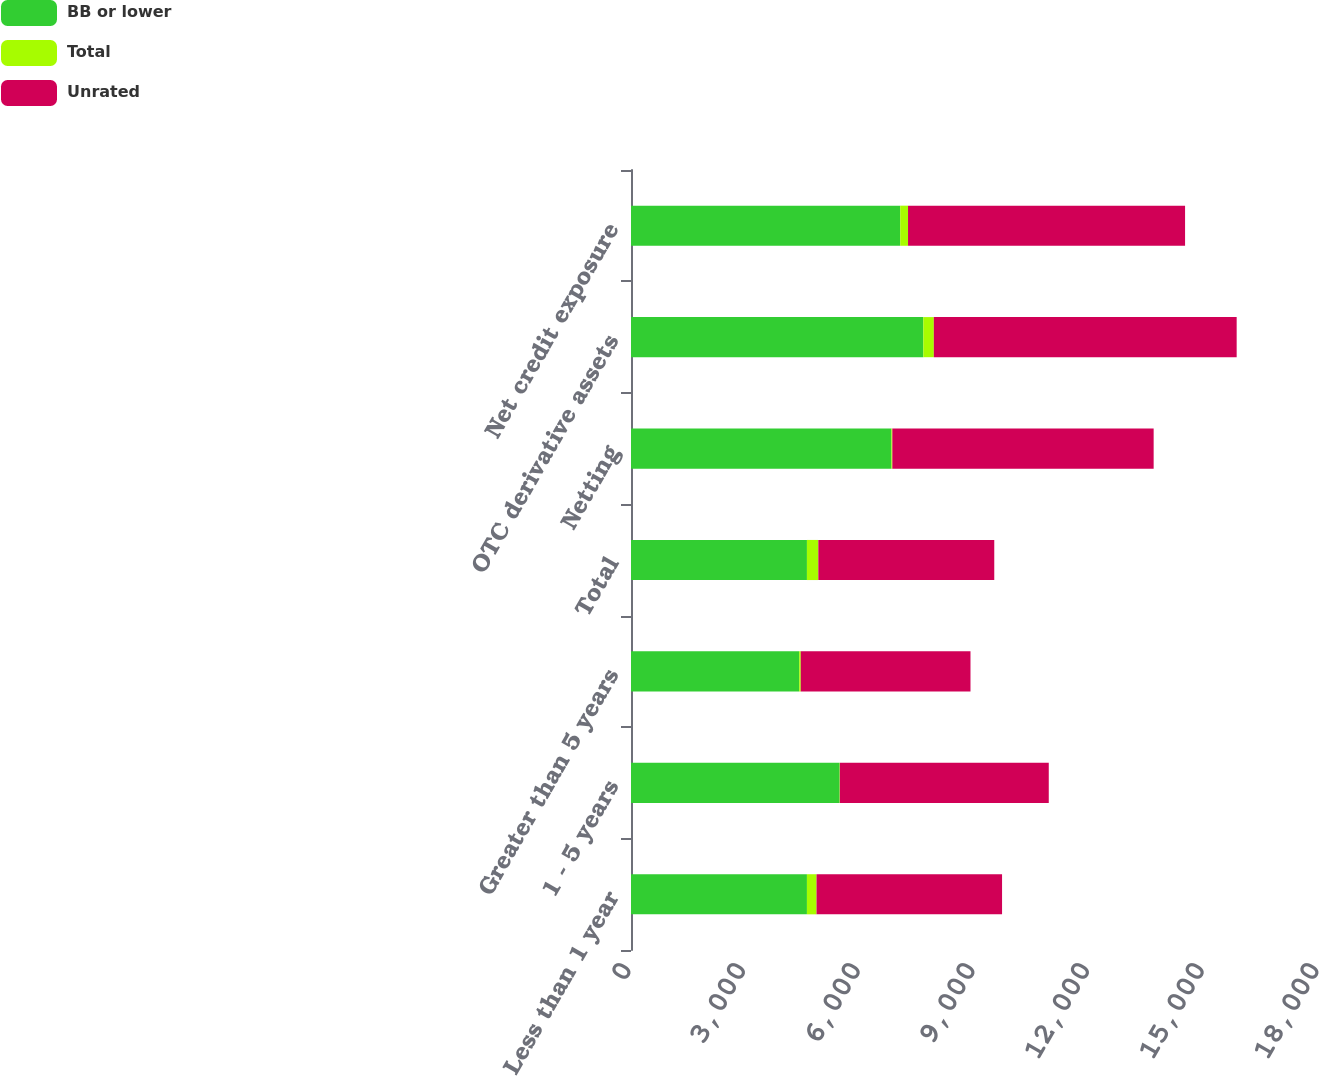Convert chart. <chart><loc_0><loc_0><loc_500><loc_500><stacked_bar_chart><ecel><fcel>Less than 1 year<fcel>1 - 5 years<fcel>Greater than 5 years<fcel>Total<fcel>Netting<fcel>OTC derivative assets<fcel>Net credit exposure<nl><fcel>BB or lower<fcel>4603<fcel>5458<fcel>4401<fcel>4603<fcel>6814<fcel>7648<fcel>7044<nl><fcel>Total<fcel>251<fcel>7<fcel>40<fcel>298<fcel>23<fcel>275<fcel>204<nl><fcel>Unrated<fcel>4854<fcel>5465<fcel>4441<fcel>4603<fcel>6837<fcel>7923<fcel>7248<nl></chart> 